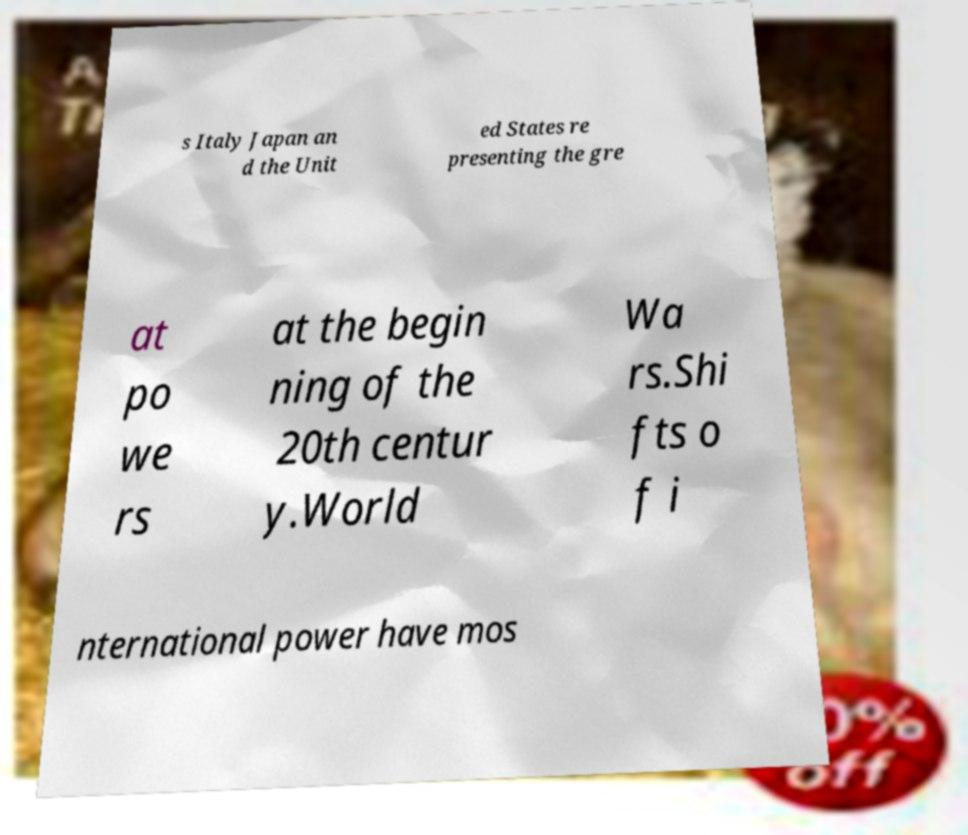There's text embedded in this image that I need extracted. Can you transcribe it verbatim? s Italy Japan an d the Unit ed States re presenting the gre at po we rs at the begin ning of the 20th centur y.World Wa rs.Shi fts o f i nternational power have mos 